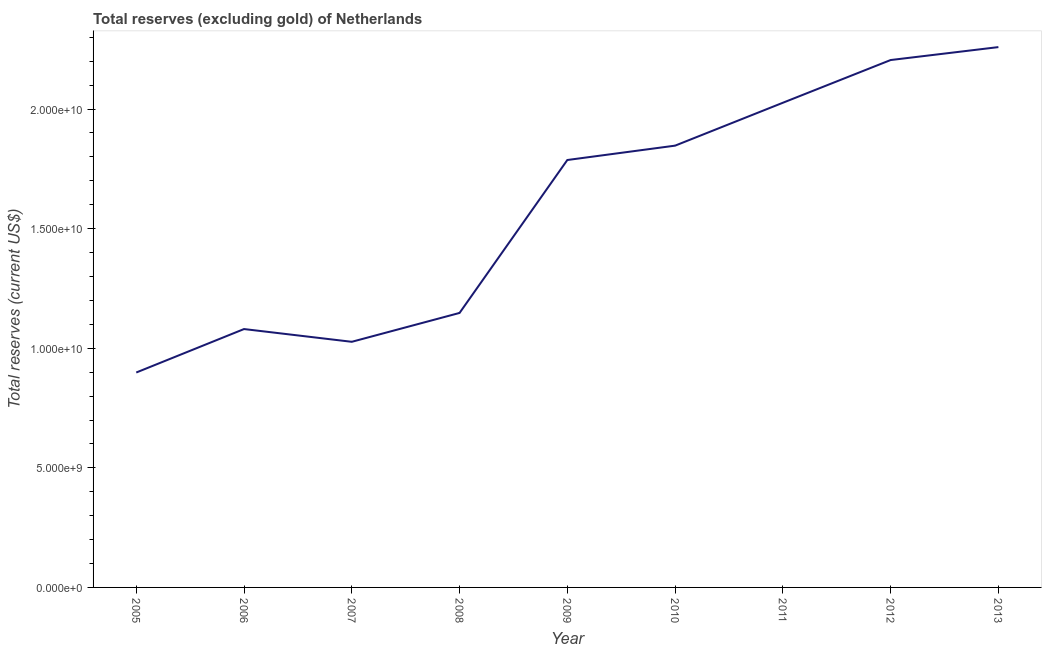What is the total reserves (excluding gold) in 2009?
Ensure brevity in your answer.  1.79e+1. Across all years, what is the maximum total reserves (excluding gold)?
Provide a succinct answer. 2.26e+1. Across all years, what is the minimum total reserves (excluding gold)?
Offer a terse response. 8.99e+09. What is the sum of the total reserves (excluding gold)?
Ensure brevity in your answer.  1.43e+11. What is the difference between the total reserves (excluding gold) in 2006 and 2013?
Keep it short and to the point. -1.18e+1. What is the average total reserves (excluding gold) per year?
Your answer should be compact. 1.59e+1. What is the median total reserves (excluding gold)?
Your answer should be very brief. 1.79e+1. In how many years, is the total reserves (excluding gold) greater than 18000000000 US$?
Offer a very short reply. 4. What is the ratio of the total reserves (excluding gold) in 2006 to that in 2013?
Give a very brief answer. 0.48. What is the difference between the highest and the second highest total reserves (excluding gold)?
Give a very brief answer. 5.41e+08. Is the sum of the total reserves (excluding gold) in 2008 and 2009 greater than the maximum total reserves (excluding gold) across all years?
Provide a short and direct response. Yes. What is the difference between the highest and the lowest total reserves (excluding gold)?
Offer a very short reply. 1.36e+1. In how many years, is the total reserves (excluding gold) greater than the average total reserves (excluding gold) taken over all years?
Ensure brevity in your answer.  5. How many lines are there?
Your response must be concise. 1. Are the values on the major ticks of Y-axis written in scientific E-notation?
Ensure brevity in your answer.  Yes. Does the graph contain grids?
Ensure brevity in your answer.  No. What is the title of the graph?
Your response must be concise. Total reserves (excluding gold) of Netherlands. What is the label or title of the X-axis?
Your answer should be compact. Year. What is the label or title of the Y-axis?
Offer a very short reply. Total reserves (current US$). What is the Total reserves (current US$) in 2005?
Offer a very short reply. 8.99e+09. What is the Total reserves (current US$) in 2006?
Provide a succinct answer. 1.08e+1. What is the Total reserves (current US$) of 2007?
Your answer should be compact. 1.03e+1. What is the Total reserves (current US$) of 2008?
Your answer should be compact. 1.15e+1. What is the Total reserves (current US$) in 2009?
Your answer should be very brief. 1.79e+1. What is the Total reserves (current US$) in 2010?
Ensure brevity in your answer.  1.85e+1. What is the Total reserves (current US$) in 2011?
Provide a succinct answer. 2.03e+1. What is the Total reserves (current US$) of 2012?
Your response must be concise. 2.21e+1. What is the Total reserves (current US$) in 2013?
Provide a short and direct response. 2.26e+1. What is the difference between the Total reserves (current US$) in 2005 and 2006?
Provide a succinct answer. -1.82e+09. What is the difference between the Total reserves (current US$) in 2005 and 2007?
Your answer should be very brief. -1.28e+09. What is the difference between the Total reserves (current US$) in 2005 and 2008?
Offer a very short reply. -2.49e+09. What is the difference between the Total reserves (current US$) in 2005 and 2009?
Your response must be concise. -8.88e+09. What is the difference between the Total reserves (current US$) in 2005 and 2010?
Offer a terse response. -9.49e+09. What is the difference between the Total reserves (current US$) in 2005 and 2011?
Your response must be concise. -1.13e+1. What is the difference between the Total reserves (current US$) in 2005 and 2012?
Provide a succinct answer. -1.31e+1. What is the difference between the Total reserves (current US$) in 2005 and 2013?
Offer a very short reply. -1.36e+1. What is the difference between the Total reserves (current US$) in 2006 and 2007?
Ensure brevity in your answer.  5.33e+08. What is the difference between the Total reserves (current US$) in 2006 and 2008?
Provide a short and direct response. -6.74e+08. What is the difference between the Total reserves (current US$) in 2006 and 2009?
Ensure brevity in your answer.  -7.07e+09. What is the difference between the Total reserves (current US$) in 2006 and 2010?
Keep it short and to the point. -7.67e+09. What is the difference between the Total reserves (current US$) in 2006 and 2011?
Your answer should be very brief. -9.46e+09. What is the difference between the Total reserves (current US$) in 2006 and 2012?
Offer a very short reply. -1.12e+1. What is the difference between the Total reserves (current US$) in 2006 and 2013?
Provide a short and direct response. -1.18e+1. What is the difference between the Total reserves (current US$) in 2007 and 2008?
Make the answer very short. -1.21e+09. What is the difference between the Total reserves (current US$) in 2007 and 2009?
Provide a short and direct response. -7.60e+09. What is the difference between the Total reserves (current US$) in 2007 and 2010?
Your answer should be compact. -8.20e+09. What is the difference between the Total reserves (current US$) in 2007 and 2011?
Your response must be concise. -9.99e+09. What is the difference between the Total reserves (current US$) in 2007 and 2012?
Ensure brevity in your answer.  -1.18e+1. What is the difference between the Total reserves (current US$) in 2007 and 2013?
Ensure brevity in your answer.  -1.23e+1. What is the difference between the Total reserves (current US$) in 2008 and 2009?
Make the answer very short. -6.39e+09. What is the difference between the Total reserves (current US$) in 2008 and 2010?
Offer a terse response. -6.99e+09. What is the difference between the Total reserves (current US$) in 2008 and 2011?
Your response must be concise. -8.79e+09. What is the difference between the Total reserves (current US$) in 2008 and 2012?
Ensure brevity in your answer.  -1.06e+1. What is the difference between the Total reserves (current US$) in 2008 and 2013?
Your answer should be compact. -1.11e+1. What is the difference between the Total reserves (current US$) in 2009 and 2010?
Keep it short and to the point. -6.01e+08. What is the difference between the Total reserves (current US$) in 2009 and 2011?
Ensure brevity in your answer.  -2.39e+09. What is the difference between the Total reserves (current US$) in 2009 and 2012?
Offer a very short reply. -4.18e+09. What is the difference between the Total reserves (current US$) in 2009 and 2013?
Provide a succinct answer. -4.72e+09. What is the difference between the Total reserves (current US$) in 2010 and 2011?
Your answer should be compact. -1.79e+09. What is the difference between the Total reserves (current US$) in 2010 and 2012?
Offer a terse response. -3.58e+09. What is the difference between the Total reserves (current US$) in 2010 and 2013?
Provide a short and direct response. -4.12e+09. What is the difference between the Total reserves (current US$) in 2011 and 2012?
Your answer should be very brief. -1.79e+09. What is the difference between the Total reserves (current US$) in 2011 and 2013?
Provide a succinct answer. -2.33e+09. What is the difference between the Total reserves (current US$) in 2012 and 2013?
Give a very brief answer. -5.41e+08. What is the ratio of the Total reserves (current US$) in 2005 to that in 2006?
Ensure brevity in your answer.  0.83. What is the ratio of the Total reserves (current US$) in 2005 to that in 2007?
Offer a terse response. 0.88. What is the ratio of the Total reserves (current US$) in 2005 to that in 2008?
Provide a succinct answer. 0.78. What is the ratio of the Total reserves (current US$) in 2005 to that in 2009?
Provide a short and direct response. 0.5. What is the ratio of the Total reserves (current US$) in 2005 to that in 2010?
Ensure brevity in your answer.  0.49. What is the ratio of the Total reserves (current US$) in 2005 to that in 2011?
Offer a terse response. 0.44. What is the ratio of the Total reserves (current US$) in 2005 to that in 2012?
Ensure brevity in your answer.  0.41. What is the ratio of the Total reserves (current US$) in 2005 to that in 2013?
Provide a succinct answer. 0.4. What is the ratio of the Total reserves (current US$) in 2006 to that in 2007?
Make the answer very short. 1.05. What is the ratio of the Total reserves (current US$) in 2006 to that in 2008?
Offer a terse response. 0.94. What is the ratio of the Total reserves (current US$) in 2006 to that in 2009?
Provide a succinct answer. 0.6. What is the ratio of the Total reserves (current US$) in 2006 to that in 2010?
Make the answer very short. 0.58. What is the ratio of the Total reserves (current US$) in 2006 to that in 2011?
Your response must be concise. 0.53. What is the ratio of the Total reserves (current US$) in 2006 to that in 2012?
Your answer should be very brief. 0.49. What is the ratio of the Total reserves (current US$) in 2006 to that in 2013?
Make the answer very short. 0.48. What is the ratio of the Total reserves (current US$) in 2007 to that in 2008?
Offer a very short reply. 0.9. What is the ratio of the Total reserves (current US$) in 2007 to that in 2009?
Ensure brevity in your answer.  0.57. What is the ratio of the Total reserves (current US$) in 2007 to that in 2010?
Give a very brief answer. 0.56. What is the ratio of the Total reserves (current US$) in 2007 to that in 2011?
Ensure brevity in your answer.  0.51. What is the ratio of the Total reserves (current US$) in 2007 to that in 2012?
Your answer should be compact. 0.47. What is the ratio of the Total reserves (current US$) in 2007 to that in 2013?
Keep it short and to the point. 0.46. What is the ratio of the Total reserves (current US$) in 2008 to that in 2009?
Give a very brief answer. 0.64. What is the ratio of the Total reserves (current US$) in 2008 to that in 2010?
Make the answer very short. 0.62. What is the ratio of the Total reserves (current US$) in 2008 to that in 2011?
Ensure brevity in your answer.  0.57. What is the ratio of the Total reserves (current US$) in 2008 to that in 2012?
Give a very brief answer. 0.52. What is the ratio of the Total reserves (current US$) in 2008 to that in 2013?
Provide a succinct answer. 0.51. What is the ratio of the Total reserves (current US$) in 2009 to that in 2010?
Make the answer very short. 0.97. What is the ratio of the Total reserves (current US$) in 2009 to that in 2011?
Give a very brief answer. 0.88. What is the ratio of the Total reserves (current US$) in 2009 to that in 2012?
Ensure brevity in your answer.  0.81. What is the ratio of the Total reserves (current US$) in 2009 to that in 2013?
Make the answer very short. 0.79. What is the ratio of the Total reserves (current US$) in 2010 to that in 2011?
Your answer should be compact. 0.91. What is the ratio of the Total reserves (current US$) in 2010 to that in 2012?
Your response must be concise. 0.84. What is the ratio of the Total reserves (current US$) in 2010 to that in 2013?
Your answer should be very brief. 0.82. What is the ratio of the Total reserves (current US$) in 2011 to that in 2012?
Provide a short and direct response. 0.92. What is the ratio of the Total reserves (current US$) in 2011 to that in 2013?
Your answer should be very brief. 0.9. 